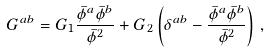<formula> <loc_0><loc_0><loc_500><loc_500>G ^ { a b } = G _ { 1 } \frac { \bar { \phi } ^ { a } \bar { \phi } ^ { b } } { \bar { \phi } ^ { 2 } } + G _ { 2 } \left ( \delta ^ { a b } - \frac { \bar { \phi } ^ { a } \bar { \phi } ^ { b } } { \bar { \phi } ^ { 2 } } \right ) \, ,</formula> 